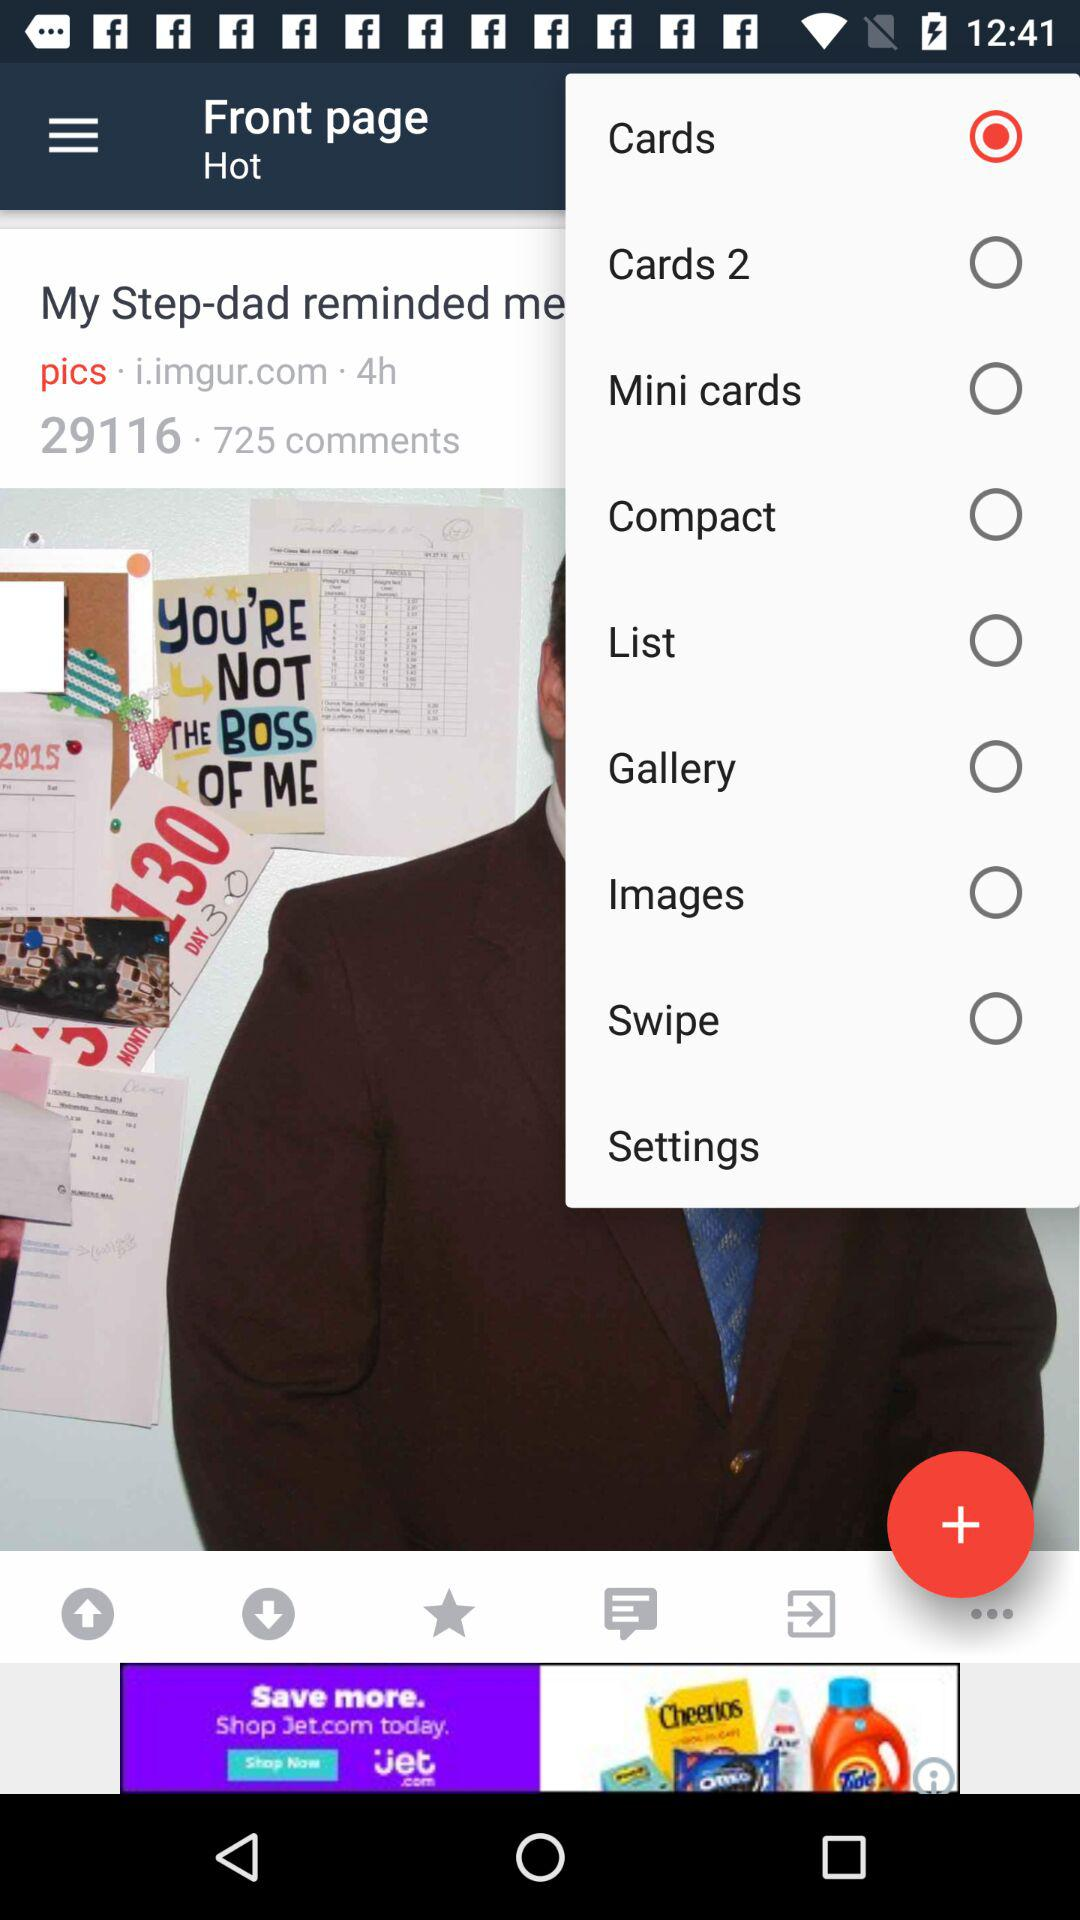How many comments are on the picture? There are 725 comments on the picture. 